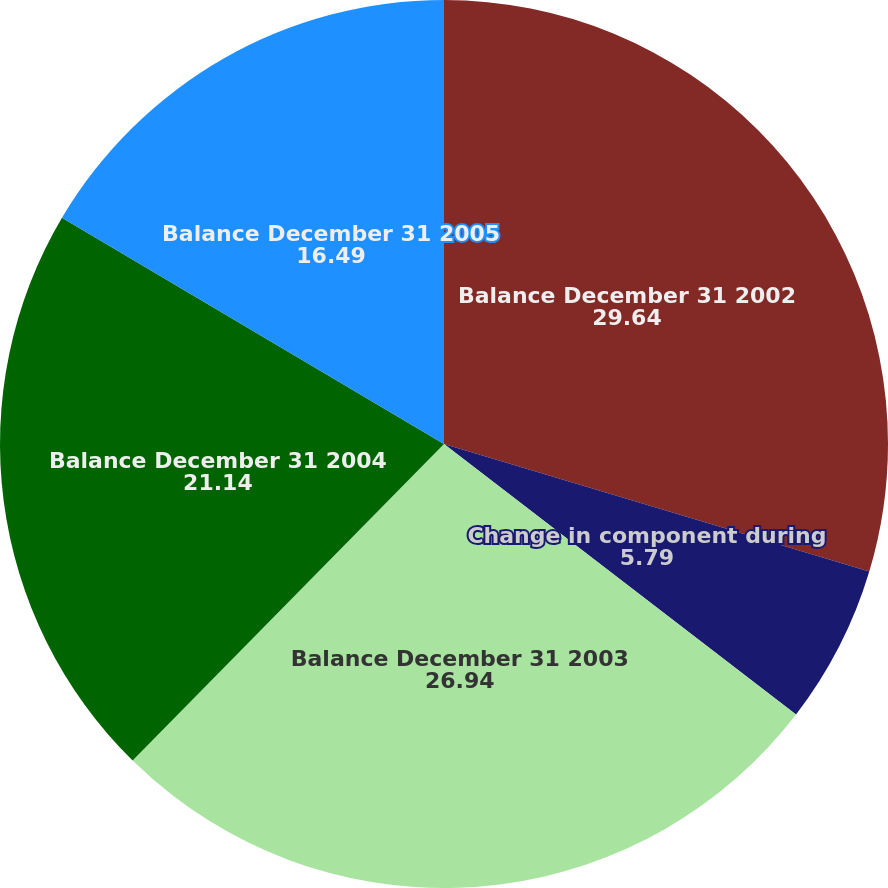Convert chart to OTSL. <chart><loc_0><loc_0><loc_500><loc_500><pie_chart><fcel>Balance December 31 2002<fcel>Change in component during<fcel>Balance December 31 2003<fcel>Balance December 31 2004<fcel>Balance December 31 2005<nl><fcel>29.64%<fcel>5.79%<fcel>26.94%<fcel>21.14%<fcel>16.49%<nl></chart> 